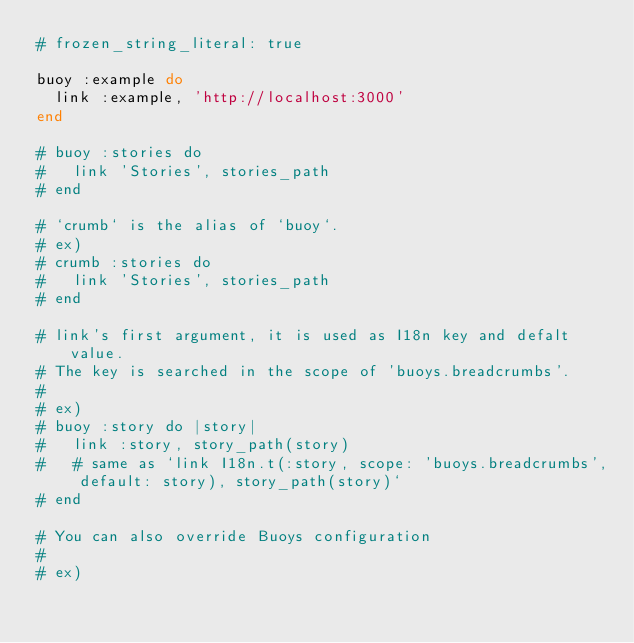<code> <loc_0><loc_0><loc_500><loc_500><_Ruby_># frozen_string_literal: true

buoy :example do
  link :example, 'http://localhost:3000'
end

# buoy :stories do
#   link 'Stories', stories_path
# end

# `crumb` is the alias of `buoy`.
# ex)
# crumb :stories do
#   link 'Stories', stories_path
# end

# link's first argument, it is used as I18n key and defalt value.
# The key is searched in the scope of 'buoys.breadcrumbs'.
#
# ex)
# buoy :story do |story|
#   link :story, story_path(story)
#   # same as `link I18n.t(:story, scope: 'buoys.breadcrumbs', default: story), story_path(story)`
# end

# You can also override Buoys configuration
#
# ex)</code> 